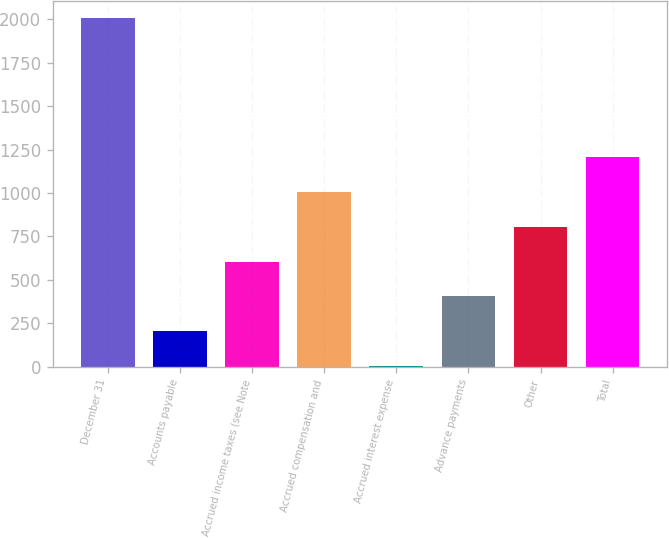Convert chart to OTSL. <chart><loc_0><loc_0><loc_500><loc_500><bar_chart><fcel>December 31<fcel>Accounts payable<fcel>Accrued income taxes (see Note<fcel>Accrued compensation and<fcel>Accrued interest expense<fcel>Advance payments<fcel>Other<fcel>Total<nl><fcel>2006<fcel>203.93<fcel>604.39<fcel>1004.85<fcel>3.7<fcel>404.16<fcel>804.62<fcel>1205.08<nl></chart> 